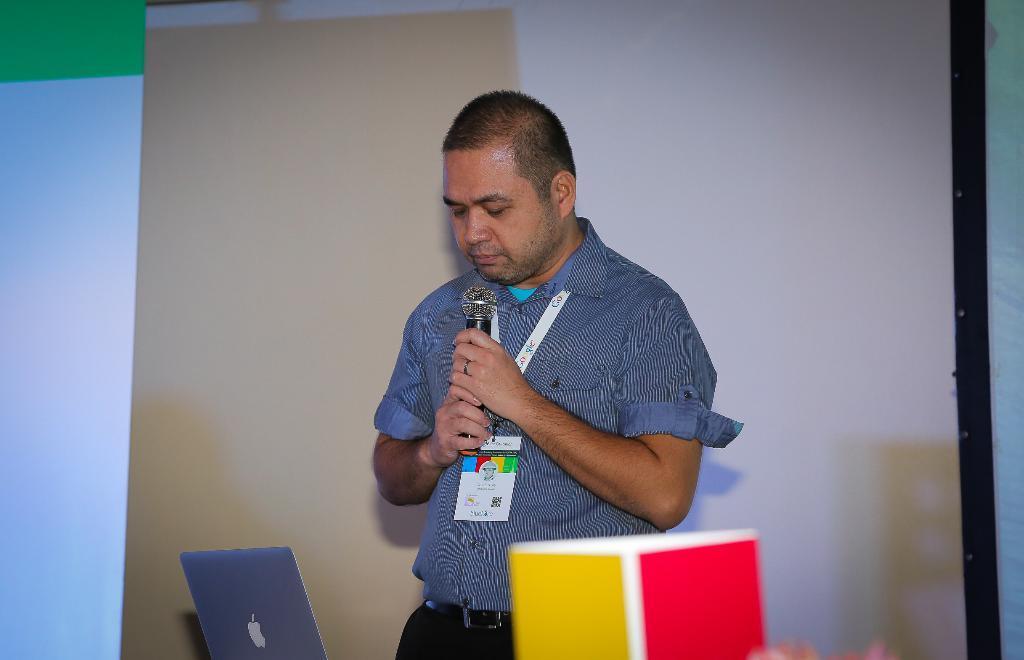Please provide a concise description of this image. In this picture I can see a man standing and holding a microphone in his hand and I can see a laptop and man wore a id card and I can see a screen on the back. 